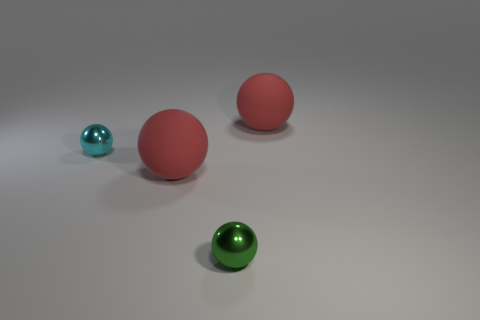How many large matte things are there?
Give a very brief answer. 2. What number of cubes are tiny yellow metallic objects or small cyan metallic objects?
Your answer should be compact. 0. What number of metal objects are in front of the ball to the right of the shiny object that is to the right of the cyan metallic object?
Your answer should be very brief. 2. There is another sphere that is the same size as the cyan metal sphere; what is its color?
Provide a succinct answer. Green. Is the number of small spheres that are on the left side of the tiny green metallic object greater than the number of tiny gray metallic cubes?
Your response must be concise. Yes. Are the small cyan thing and the green thing made of the same material?
Provide a succinct answer. Yes. How many things are either red rubber balls to the left of the tiny green object or spheres?
Offer a very short reply. 4. What number of other things are the same size as the green object?
Ensure brevity in your answer.  1. Is the number of tiny metal objects that are on the left side of the small cyan sphere the same as the number of big red rubber balls behind the green thing?
Your answer should be compact. No. What is the color of the other tiny thing that is the same shape as the cyan metallic thing?
Your response must be concise. Green. 